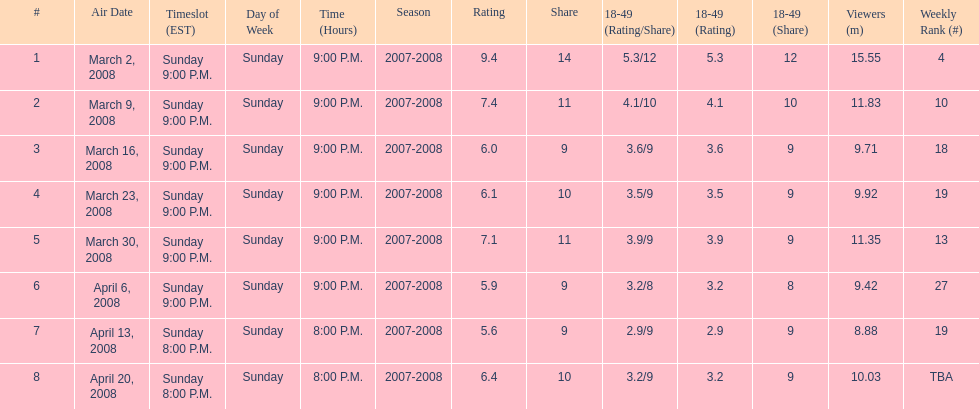What time slot did the show have for its first 6 episodes? Sunday 9:00 P.M. 